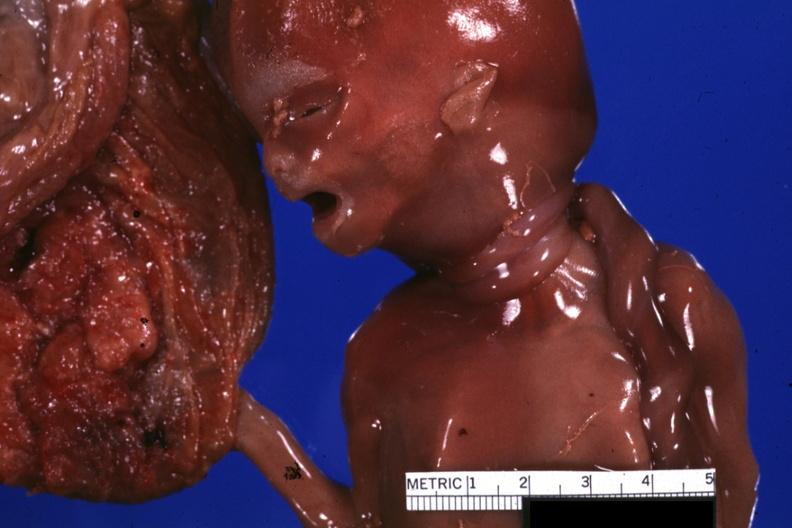how many loops does this image show close-up of of umbilical cord around neck?
Answer the question using a single word or phrase. Two 